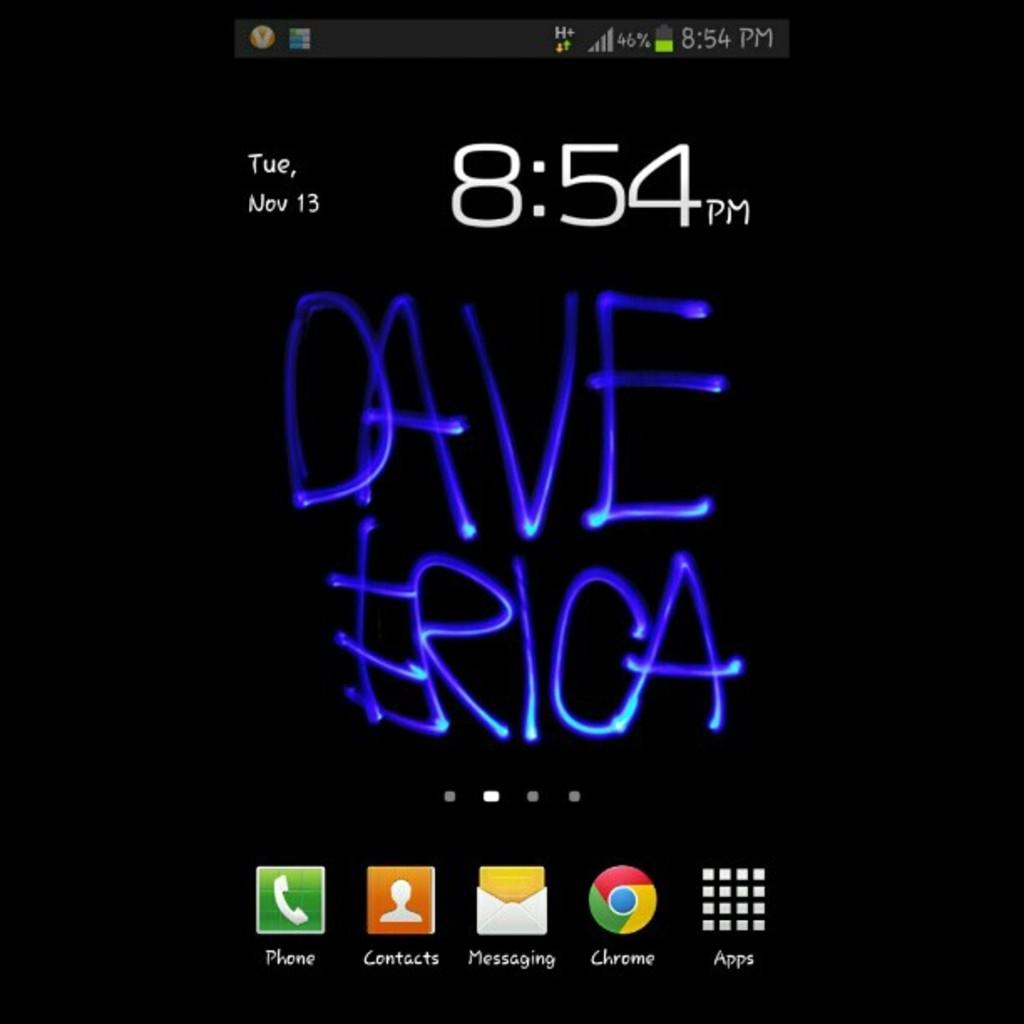Is today the 13th?
Keep it short and to the point. Yes. Whose name is on this?
Provide a succinct answer. Dave erica. 